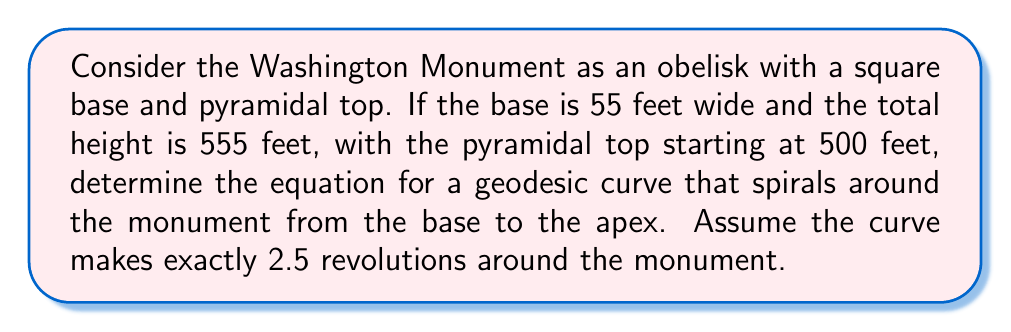Could you help me with this problem? Let's approach this step-by-step:

1) First, we need to set up a coordinate system. Let's use cylindrical coordinates $(r, \theta, z)$, where $z$ is the height.

2) The monument consists of two parts:
   - A rectangular prism from $z = 0$ to $z = 500$
   - A pyramid from $z = 500$ to $z = 555$

3) For the rectangular prism part $(0 \leq z \leq 500)$:
   $r = 27.5$ (half the width of the base)

4) For the pyramidal part $(500 < z \leq 555)$:
   $r = 27.5 \cdot (1 - \frac{z-500}{55})$

5) The geodesic makes 2.5 revolutions, so $\theta$ goes from 0 to $5\pi$.

6) We can parameterize the curve using a parameter $t$ $(0 \leq t \leq 1)$:

   $\theta(t) = 5\pi t$
   
   $z(t) = 555t$

7) For $r(t)$, we need a piecewise function:

   $$r(t) = \begin{cases}
   27.5 & \text{if } 0 \leq t \leq \frac{500}{555} \\
   27.5 \cdot (1 - \frac{555t-500}{55}) & \text{if } \frac{500}{555} < t \leq 1
   \end{cases}$$

8) The geodesic curve can be described parametrically as:

   $$x(t) = r(t) \cos(5\pi t)$$
   $$y(t) = r(t) \sin(5\pi t)$$
   $$z(t) = 555t$$

   Where $r(t)$ is as defined in step 7.
Answer: $$(x,y,z) = (r(t)\cos(5\pi t), r(t)\sin(5\pi t), 555t)$$
where
$$r(t) = \begin{cases}
27.5 & \text{if } 0 \leq t \leq \frac{500}{555} \\
27.5 \cdot (1 - \frac{555t-500}{55}) & \text{if } \frac{500}{555} < t \leq 1
\end{cases}$$ 